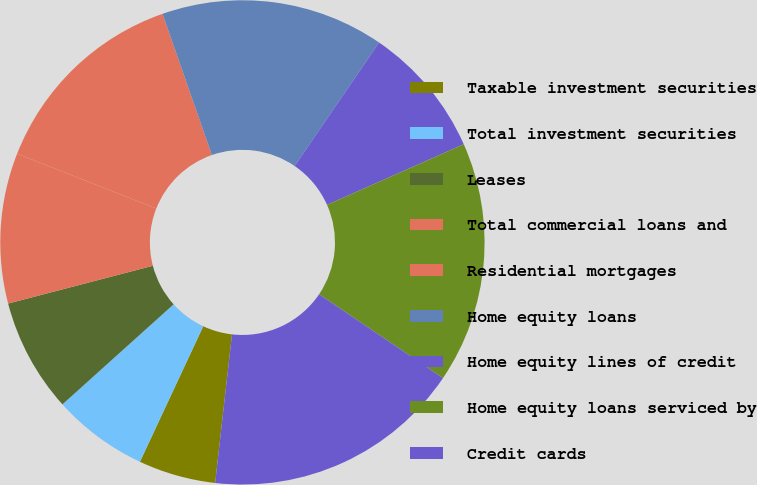<chart> <loc_0><loc_0><loc_500><loc_500><pie_chart><fcel>Taxable investment securities<fcel>Total investment securities<fcel>Leases<fcel>Total commercial loans and<fcel>Residential mortgages<fcel>Home equity loans<fcel>Home equity lines of credit<fcel>Home equity loans serviced by<fcel>Credit cards<nl><fcel>5.16%<fcel>6.38%<fcel>7.6%<fcel>10.03%<fcel>13.68%<fcel>14.9%<fcel>8.81%<fcel>16.11%<fcel>17.33%<nl></chart> 